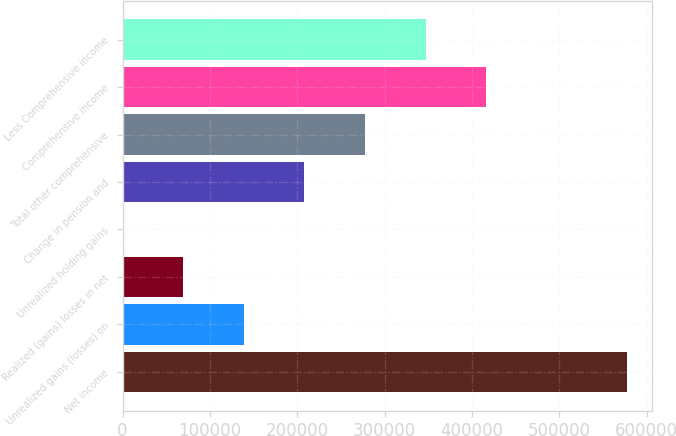Convert chart. <chart><loc_0><loc_0><loc_500><loc_500><bar_chart><fcel>Net income<fcel>Unrealized gains (losses) on<fcel>Realized (gains) losses in net<fcel>Unrealized holding gains<fcel>Change in pension and<fcel>Total other comprehensive<fcel>Comprehensive income<fcel>Less Comprehensive income<nl><fcel>576961<fcel>138831<fcel>69503.8<fcel>177<fcel>208157<fcel>277484<fcel>416138<fcel>346811<nl></chart> 